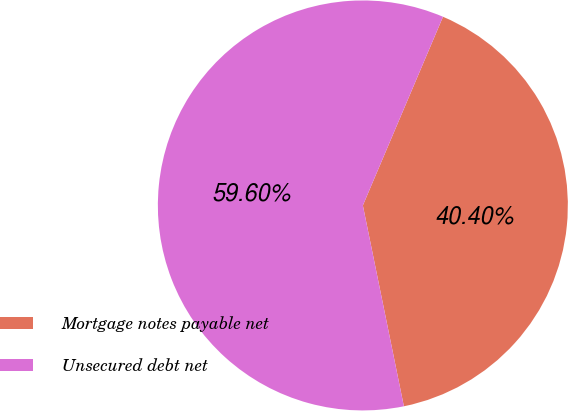Convert chart to OTSL. <chart><loc_0><loc_0><loc_500><loc_500><pie_chart><fcel>Mortgage notes payable net<fcel>Unsecured debt net<nl><fcel>40.4%<fcel>59.6%<nl></chart> 